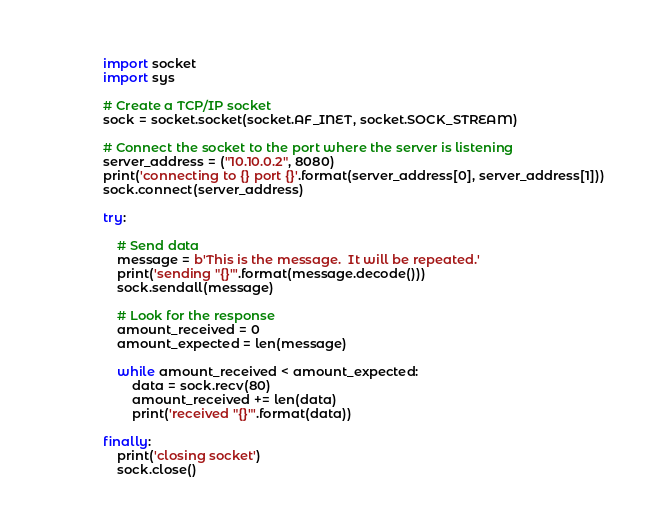Convert code to text. <code><loc_0><loc_0><loc_500><loc_500><_Python_>import socket
import sys

# Create a TCP/IP socket
sock = socket.socket(socket.AF_INET, socket.SOCK_STREAM)

# Connect the socket to the port where the server is listening
server_address = ("10.10.0.2", 8080)
print('connecting to {} port {}'.format(server_address[0], server_address[1]))
sock.connect(server_address)

try:
    
    # Send data
    message = b'This is the message.  It will be repeated.'
    print('sending "{}"'.format(message.decode()))
    sock.sendall(message)

    # Look for the response
    amount_received = 0
    amount_expected = len(message)
    
    while amount_received < amount_expected:
        data = sock.recv(80)
        amount_received += len(data)
        print('received "{}"'.format(data))

finally:
    print('closing socket')
    sock.close()</code> 